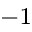Convert formula to latex. <formula><loc_0><loc_0><loc_500><loc_500>^ { 1 }</formula> 